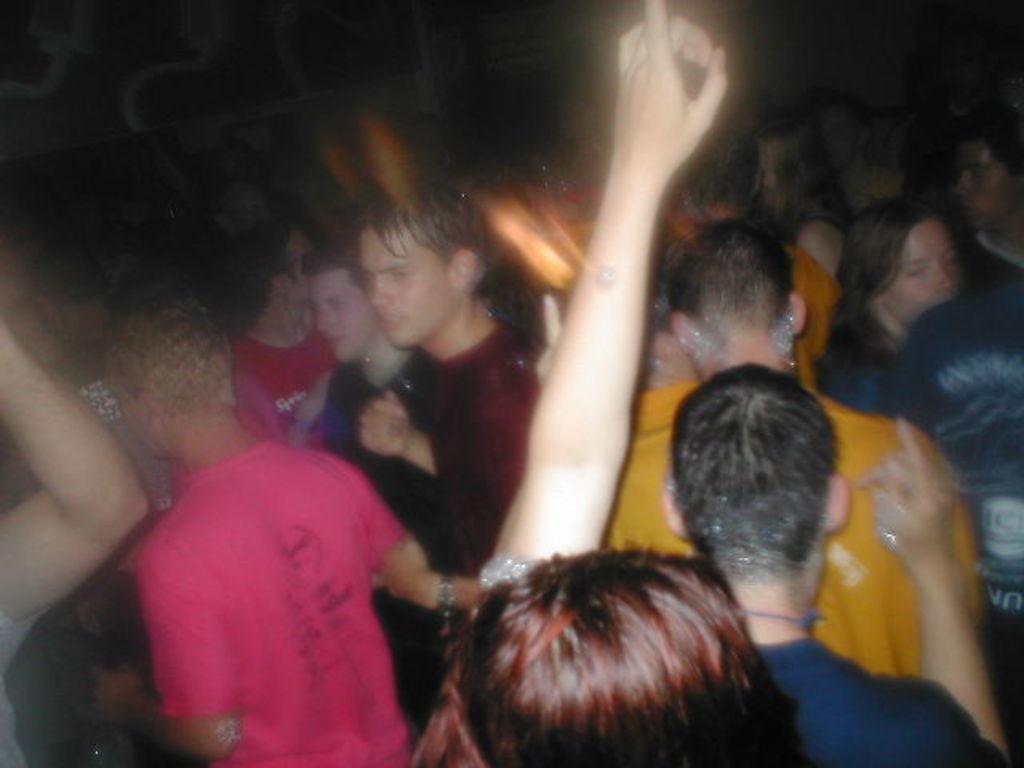How would you summarize this image in a sentence or two? In this picture we can see a group of people and in the background it is dark. 